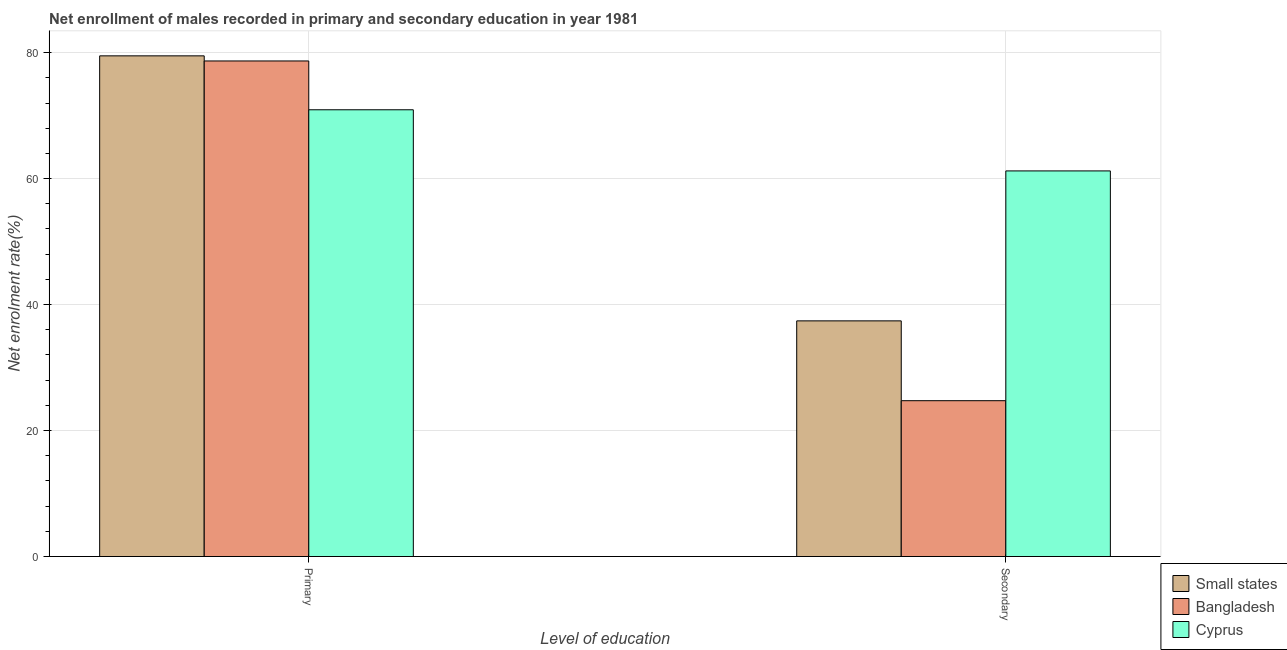How many groups of bars are there?
Ensure brevity in your answer.  2. Are the number of bars on each tick of the X-axis equal?
Your answer should be compact. Yes. How many bars are there on the 1st tick from the right?
Your response must be concise. 3. What is the label of the 1st group of bars from the left?
Provide a short and direct response. Primary. What is the enrollment rate in primary education in Cyprus?
Ensure brevity in your answer.  70.92. Across all countries, what is the maximum enrollment rate in secondary education?
Your response must be concise. 61.22. Across all countries, what is the minimum enrollment rate in primary education?
Your response must be concise. 70.92. In which country was the enrollment rate in secondary education maximum?
Make the answer very short. Cyprus. What is the total enrollment rate in secondary education in the graph?
Your response must be concise. 123.37. What is the difference between the enrollment rate in primary education in Small states and that in Cyprus?
Provide a short and direct response. 8.56. What is the difference between the enrollment rate in secondary education in Bangladesh and the enrollment rate in primary education in Cyprus?
Ensure brevity in your answer.  -46.19. What is the average enrollment rate in primary education per country?
Your answer should be very brief. 76.36. What is the difference between the enrollment rate in secondary education and enrollment rate in primary education in Cyprus?
Your answer should be very brief. -9.71. What is the ratio of the enrollment rate in primary education in Bangladesh to that in Small states?
Ensure brevity in your answer.  0.99. Is the enrollment rate in secondary education in Cyprus less than that in Bangladesh?
Offer a very short reply. No. In how many countries, is the enrollment rate in primary education greater than the average enrollment rate in primary education taken over all countries?
Provide a succinct answer. 2. What does the 2nd bar from the right in Primary represents?
Your answer should be compact. Bangladesh. Are all the bars in the graph horizontal?
Your response must be concise. No. Are the values on the major ticks of Y-axis written in scientific E-notation?
Your answer should be very brief. No. How many legend labels are there?
Give a very brief answer. 3. What is the title of the graph?
Give a very brief answer. Net enrollment of males recorded in primary and secondary education in year 1981. Does "Angola" appear as one of the legend labels in the graph?
Give a very brief answer. No. What is the label or title of the X-axis?
Offer a terse response. Level of education. What is the label or title of the Y-axis?
Offer a very short reply. Net enrolment rate(%). What is the Net enrolment rate(%) of Small states in Primary?
Provide a short and direct response. 79.49. What is the Net enrolment rate(%) of Bangladesh in Primary?
Offer a very short reply. 78.68. What is the Net enrolment rate(%) in Cyprus in Primary?
Offer a terse response. 70.92. What is the Net enrolment rate(%) in Small states in Secondary?
Ensure brevity in your answer.  37.41. What is the Net enrolment rate(%) in Bangladesh in Secondary?
Your answer should be compact. 24.74. What is the Net enrolment rate(%) of Cyprus in Secondary?
Your answer should be compact. 61.22. Across all Level of education, what is the maximum Net enrolment rate(%) of Small states?
Give a very brief answer. 79.49. Across all Level of education, what is the maximum Net enrolment rate(%) of Bangladesh?
Your response must be concise. 78.68. Across all Level of education, what is the maximum Net enrolment rate(%) of Cyprus?
Offer a terse response. 70.92. Across all Level of education, what is the minimum Net enrolment rate(%) of Small states?
Make the answer very short. 37.41. Across all Level of education, what is the minimum Net enrolment rate(%) in Bangladesh?
Your response must be concise. 24.74. Across all Level of education, what is the minimum Net enrolment rate(%) in Cyprus?
Make the answer very short. 61.22. What is the total Net enrolment rate(%) in Small states in the graph?
Provide a succinct answer. 116.9. What is the total Net enrolment rate(%) of Bangladesh in the graph?
Your response must be concise. 103.42. What is the total Net enrolment rate(%) in Cyprus in the graph?
Provide a succinct answer. 132.14. What is the difference between the Net enrolment rate(%) of Small states in Primary and that in Secondary?
Provide a succinct answer. 42.07. What is the difference between the Net enrolment rate(%) of Bangladesh in Primary and that in Secondary?
Your answer should be compact. 53.94. What is the difference between the Net enrolment rate(%) of Cyprus in Primary and that in Secondary?
Your answer should be compact. 9.71. What is the difference between the Net enrolment rate(%) of Small states in Primary and the Net enrolment rate(%) of Bangladesh in Secondary?
Your answer should be compact. 54.75. What is the difference between the Net enrolment rate(%) in Small states in Primary and the Net enrolment rate(%) in Cyprus in Secondary?
Give a very brief answer. 18.27. What is the difference between the Net enrolment rate(%) of Bangladesh in Primary and the Net enrolment rate(%) of Cyprus in Secondary?
Your response must be concise. 17.46. What is the average Net enrolment rate(%) in Small states per Level of education?
Provide a succinct answer. 58.45. What is the average Net enrolment rate(%) of Bangladesh per Level of education?
Give a very brief answer. 51.71. What is the average Net enrolment rate(%) in Cyprus per Level of education?
Your answer should be compact. 66.07. What is the difference between the Net enrolment rate(%) of Small states and Net enrolment rate(%) of Bangladesh in Primary?
Your answer should be very brief. 0.81. What is the difference between the Net enrolment rate(%) of Small states and Net enrolment rate(%) of Cyprus in Primary?
Make the answer very short. 8.56. What is the difference between the Net enrolment rate(%) of Bangladesh and Net enrolment rate(%) of Cyprus in Primary?
Offer a terse response. 7.75. What is the difference between the Net enrolment rate(%) of Small states and Net enrolment rate(%) of Bangladesh in Secondary?
Offer a very short reply. 12.67. What is the difference between the Net enrolment rate(%) of Small states and Net enrolment rate(%) of Cyprus in Secondary?
Offer a terse response. -23.81. What is the difference between the Net enrolment rate(%) of Bangladesh and Net enrolment rate(%) of Cyprus in Secondary?
Keep it short and to the point. -36.48. What is the ratio of the Net enrolment rate(%) in Small states in Primary to that in Secondary?
Your answer should be very brief. 2.12. What is the ratio of the Net enrolment rate(%) in Bangladesh in Primary to that in Secondary?
Give a very brief answer. 3.18. What is the ratio of the Net enrolment rate(%) of Cyprus in Primary to that in Secondary?
Provide a short and direct response. 1.16. What is the difference between the highest and the second highest Net enrolment rate(%) in Small states?
Your answer should be very brief. 42.07. What is the difference between the highest and the second highest Net enrolment rate(%) of Bangladesh?
Your answer should be very brief. 53.94. What is the difference between the highest and the second highest Net enrolment rate(%) of Cyprus?
Offer a very short reply. 9.71. What is the difference between the highest and the lowest Net enrolment rate(%) of Small states?
Offer a very short reply. 42.07. What is the difference between the highest and the lowest Net enrolment rate(%) in Bangladesh?
Your response must be concise. 53.94. What is the difference between the highest and the lowest Net enrolment rate(%) of Cyprus?
Make the answer very short. 9.71. 